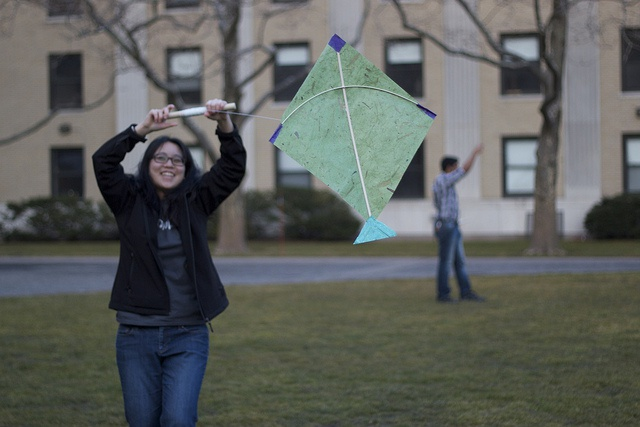Describe the objects in this image and their specific colors. I can see people in gray, black, navy, and darkblue tones, kite in gray and darkgray tones, and people in gray, black, and navy tones in this image. 